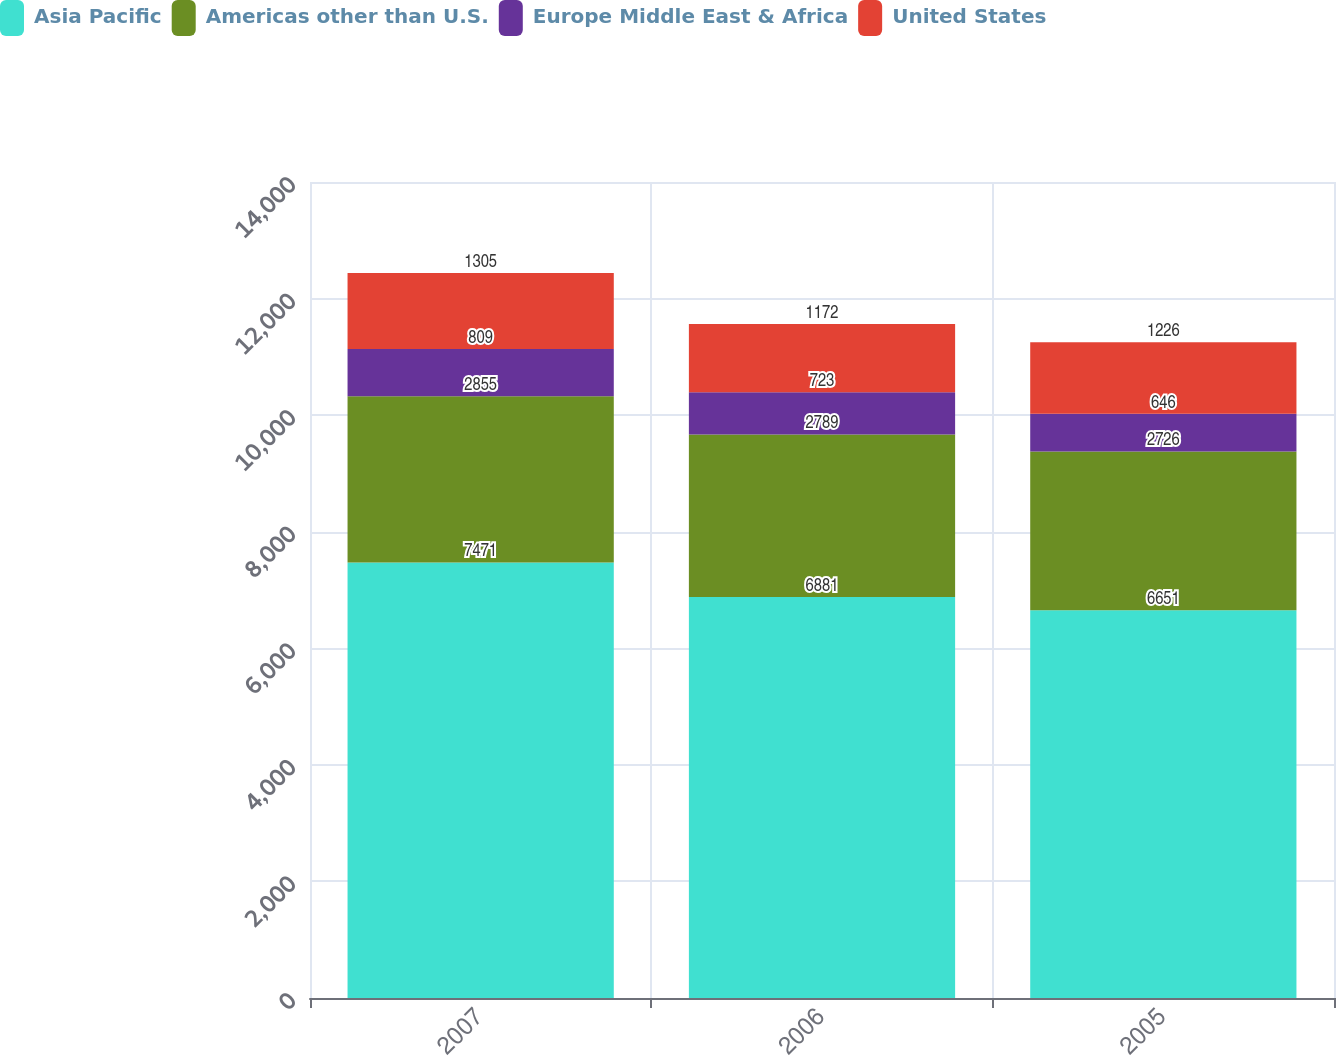<chart> <loc_0><loc_0><loc_500><loc_500><stacked_bar_chart><ecel><fcel>2007<fcel>2006<fcel>2005<nl><fcel>Asia Pacific<fcel>7471<fcel>6881<fcel>6651<nl><fcel>Americas other than U.S.<fcel>2855<fcel>2789<fcel>2726<nl><fcel>Europe Middle East & Africa<fcel>809<fcel>723<fcel>646<nl><fcel>United States<fcel>1305<fcel>1172<fcel>1226<nl></chart> 